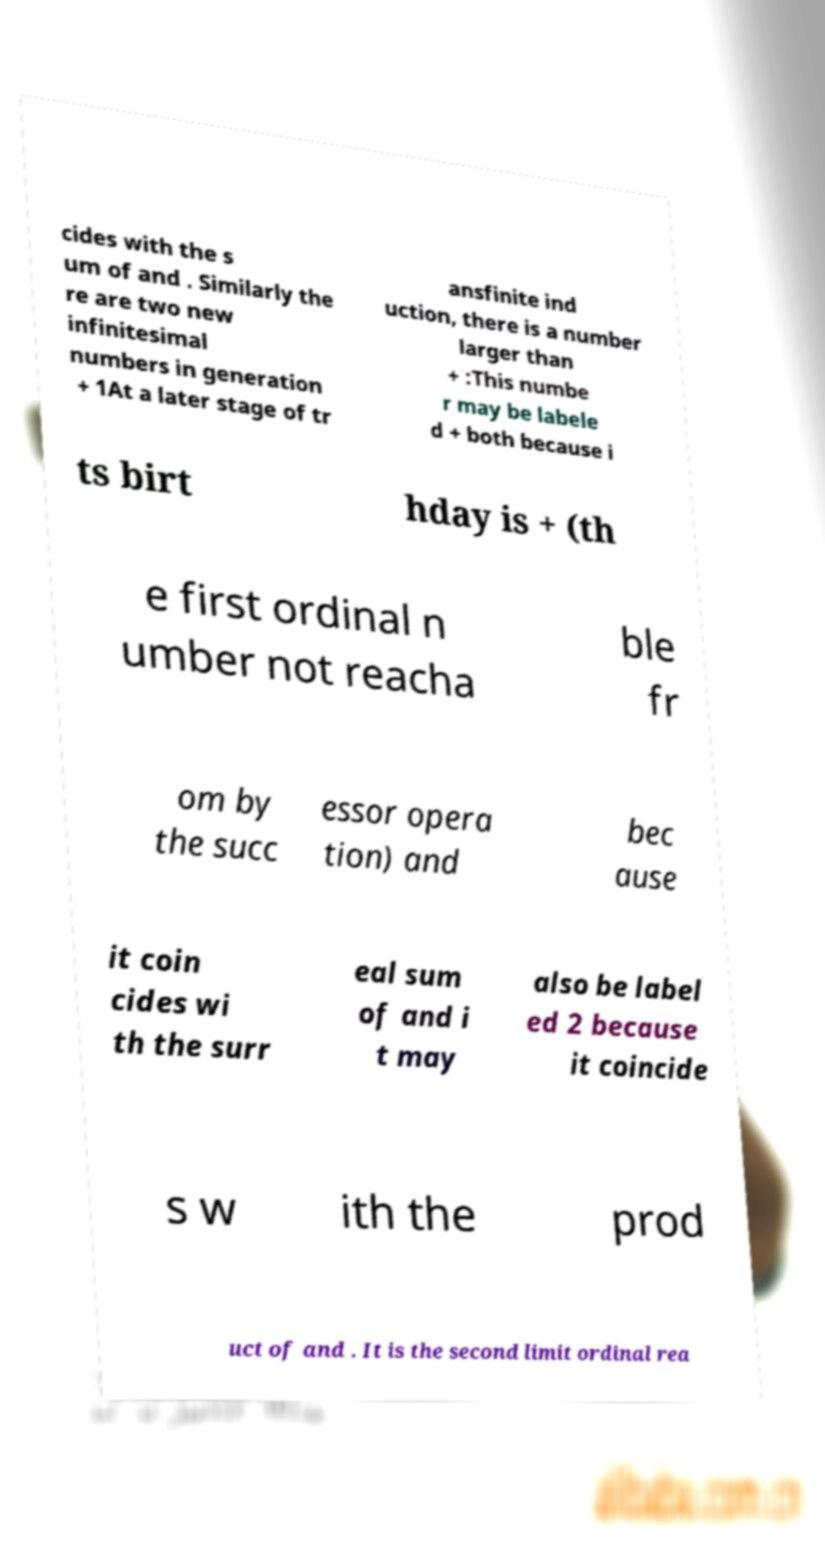There's text embedded in this image that I need extracted. Can you transcribe it verbatim? cides with the s um of and . Similarly the re are two new infinitesimal numbers in generation + 1At a later stage of tr ansfinite ind uction, there is a number larger than + :This numbe r may be labele d + both because i ts birt hday is + (th e first ordinal n umber not reacha ble fr om by the succ essor opera tion) and bec ause it coin cides wi th the surr eal sum of and i t may also be label ed 2 because it coincide s w ith the prod uct of and . It is the second limit ordinal rea 